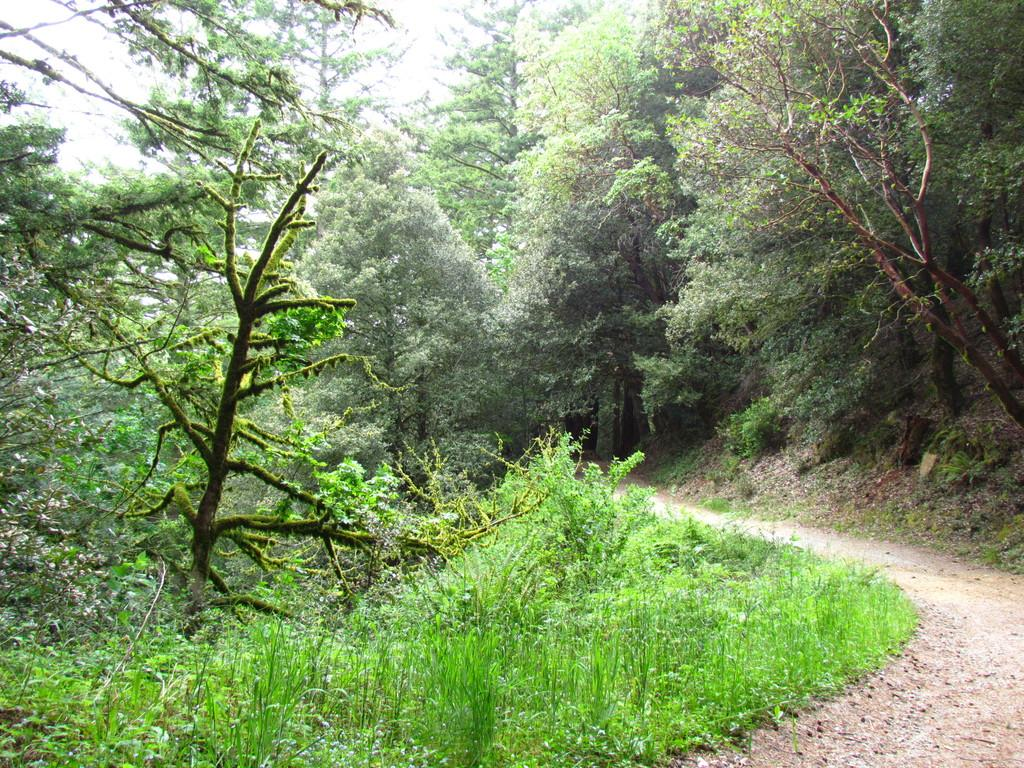What type of vegetation is present in the image? The image contains plants, grass, and trees. Can you describe the ground in the image? There is grass in the image. What is located on the right side of the image? There is a path on the right side of the image. What can be seen in the top right area of the image? The top right area of the image includes trees, dry leaves, plants, and soil. What type of education is being offered in the image? There is no indication of education being offered in the image; it primarily features vegetation and a path. Can you describe the person in the image? There is no person present in the image. 